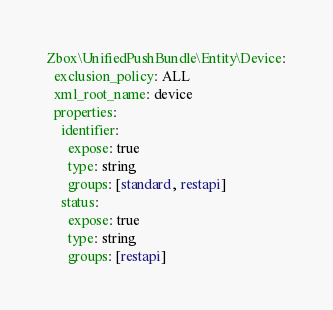Convert code to text. <code><loc_0><loc_0><loc_500><loc_500><_YAML_>Zbox\UnifiedPushBundle\Entity\Device:
  exclusion_policy: ALL
  xml_root_name: device
  properties:
    identifier:
      expose: true
      type: string
      groups: [standard, restapi]
    status:
      expose: true
      type: string
      groups: [restapi]
</code> 